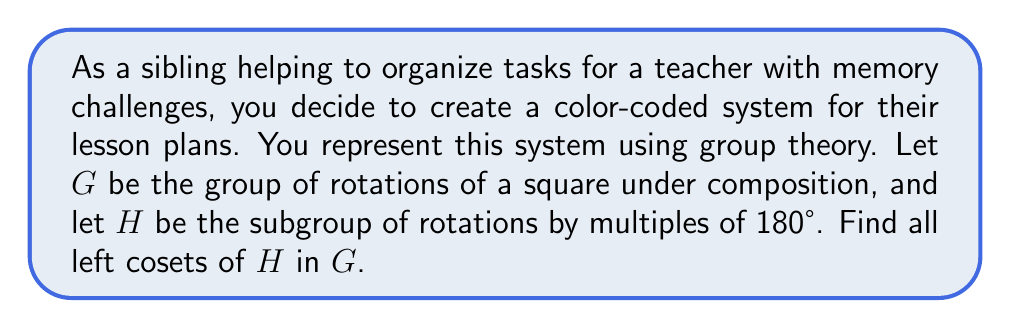Give your solution to this math problem. Let's approach this step-by-step:

1) First, we need to identify the elements of $G$ and $H$:

   $G = \{e, r_{90}, r_{180}, r_{270}\}$, where $e$ is the identity (0° rotation) and $r_\theta$ represents a counterclockwise rotation by $\theta$ degrees.

   $H = \{e, r_{180}\}$

2) To find the left cosets, we need to multiply each element of $G$ by $H$ from the left:

3) The left cosets are of the form $gH$ where $g \in G$:

   For $g = e$: 
   $eH = \{eh : h \in H\} = \{e, r_{180}\}$

   For $g = r_{90}$:
   $r_{90}H = \{r_{90}h : h \in H\} = \{r_{90}, r_{270}\}$

   For $g = r_{180}$:
   $r_{180}H = \{r_{180}h : h \in H\} = \{r_{180}, e\} = \{e, r_{180}\} = H$

   For $g = r_{270}$:
   $r_{270}H = \{r_{270}h : h \in H\} = \{r_{270}, r_{90}\}$

4) We can see that $r_{270}H = r_{90}H$, as they contain the same elements.

5) Therefore, there are only two distinct left cosets:
   $H = \{e, r_{180}\}$ and $r_{90}H = \{r_{90}, r_{270}\}$

This division into two cosets could represent two different colors in the teacher's organizational system, helping to categorize lessons into two main groups.
Answer: The left cosets of $H$ in $G$ are:
$H = \{e, r_{180}\}$ and $r_{90}H = \{r_{90}, r_{270}\}$ 